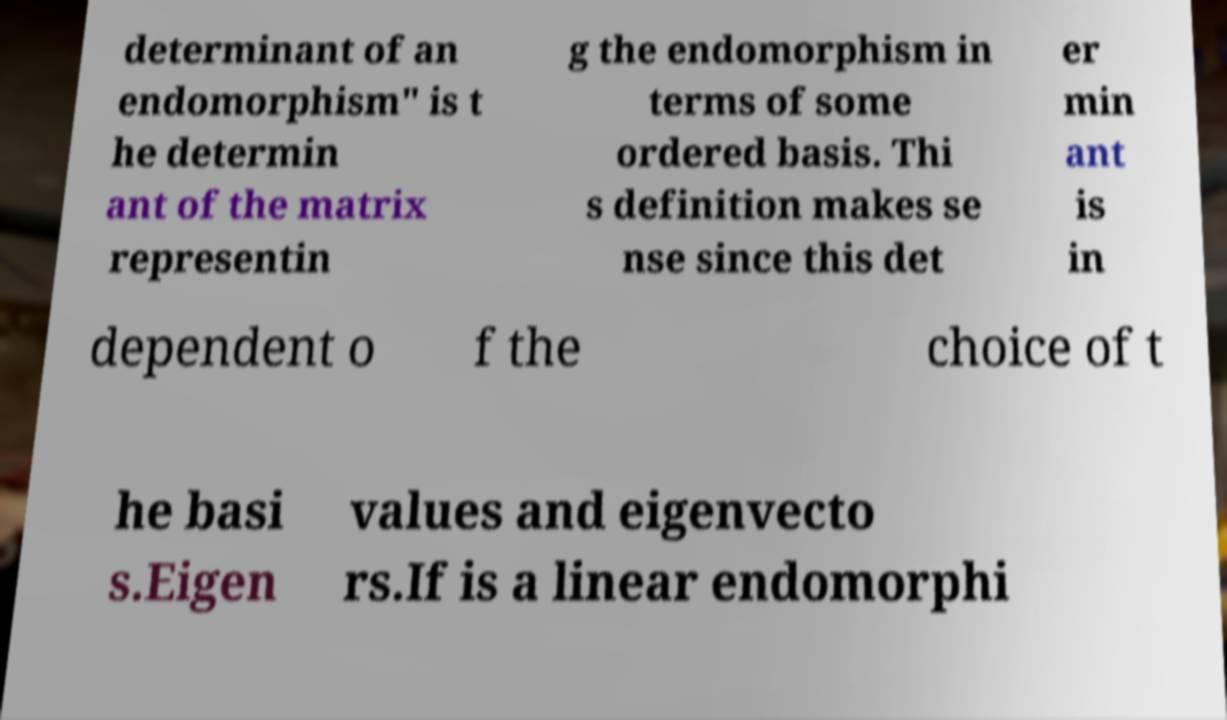Please identify and transcribe the text found in this image. determinant of an endomorphism" is t he determin ant of the matrix representin g the endomorphism in terms of some ordered basis. Thi s definition makes se nse since this det er min ant is in dependent o f the choice of t he basi s.Eigen values and eigenvecto rs.If is a linear endomorphi 